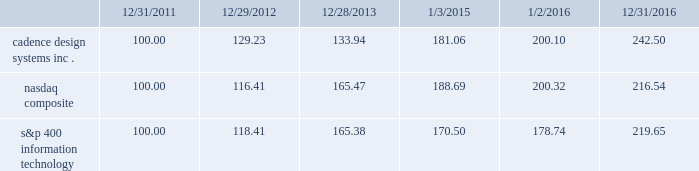Stockholder return performance graph the following graph compares the cumulative 5-year total stockholder return on our common stock relative to the cumulative total return of the nasdaq composite index and the s&p 400 information technology index .
The graph assumes that the value of the investment in our common stock and in each index on december 31 , 2011 ( including reinvestment of dividends ) was $ 100 and tracks it each year thereafter on the last day of our fiscal year through december 31 , 2016 and , for each index , on the last day of the calendar year .
Comparison of 5 year cumulative total return* among cadence design systems , inc. , the nasdaq composite index , and s&p 400 information technology cadence design systems , inc .
Nasdaq composite s&p 400 information technology 12/31/1612/28/13 1/2/1612/31/11 1/3/1512/29/12 *$ 100 invested on 12/31/11 in stock or index , including reinvestment of dividends .
Indexes calculated on month-end basis .
Copyright a9 2017 standard & poor 2019s , a division of s&p global .
All rights reserved. .
The stock price performance included in this graph is not necessarily indicative of future stock price performance. .
What is the rate of return of an investment in nasdaq composite from the end of the year in 2015 to the end of the year in 2016? 
Computations: ((200.32 - 188.69) / 188.69)
Answer: 0.06164. Stockholder return performance graph the following graph compares the cumulative 5-year total stockholder return on our common stock relative to the cumulative total return of the nasdaq composite index and the s&p 400 information technology index .
The graph assumes that the value of the investment in our common stock and in each index on december 31 , 2011 ( including reinvestment of dividends ) was $ 100 and tracks it each year thereafter on the last day of our fiscal year through december 31 , 2016 and , for each index , on the last day of the calendar year .
Comparison of 5 year cumulative total return* among cadence design systems , inc. , the nasdaq composite index , and s&p 400 information technology cadence design systems , inc .
Nasdaq composite s&p 400 information technology 12/31/1612/28/13 1/2/1612/31/11 1/3/1512/29/12 *$ 100 invested on 12/31/11 in stock or index , including reinvestment of dividends .
Indexes calculated on month-end basis .
Copyright a9 2017 standard & poor 2019s , a division of s&p global .
All rights reserved. .
The stock price performance included in this graph is not necessarily indicative of future stock price performance. .
What was the difference in percentage cumulative 5-year total stockholder return on cadence design systems inc . common stock and the s&p 400 information technology for the period ended 12/31/2016? 
Computations: (((242.50 - 100) / 100) - ((219.65 - 100) / 100))
Answer: 0.2285. 